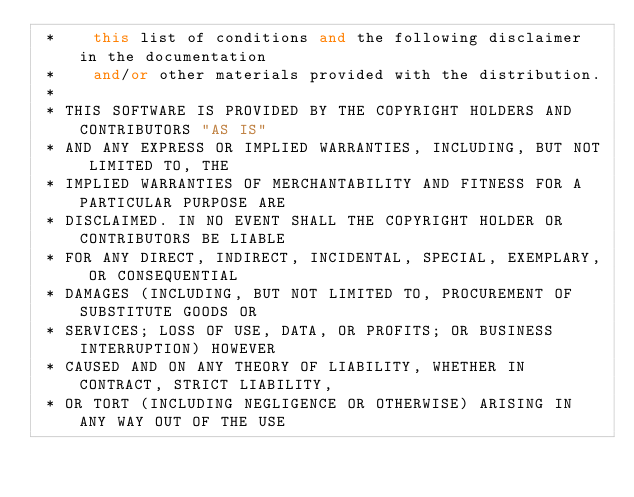Convert code to text. <code><loc_0><loc_0><loc_500><loc_500><_C++_> *    this list of conditions and the following disclaimer in the documentation
 *    and/or other materials provided with the distribution.
 *
 * THIS SOFTWARE IS PROVIDED BY THE COPYRIGHT HOLDERS AND CONTRIBUTORS "AS IS"
 * AND ANY EXPRESS OR IMPLIED WARRANTIES, INCLUDING, BUT NOT LIMITED TO, THE
 * IMPLIED WARRANTIES OF MERCHANTABILITY AND FITNESS FOR A PARTICULAR PURPOSE ARE
 * DISCLAIMED. IN NO EVENT SHALL THE COPYRIGHT HOLDER OR CONTRIBUTORS BE LIABLE
 * FOR ANY DIRECT, INDIRECT, INCIDENTAL, SPECIAL, EXEMPLARY, OR CONSEQUENTIAL
 * DAMAGES (INCLUDING, BUT NOT LIMITED TO, PROCUREMENT OF SUBSTITUTE GOODS OR
 * SERVICES; LOSS OF USE, DATA, OR PROFITS; OR BUSINESS INTERRUPTION) HOWEVER
 * CAUSED AND ON ANY THEORY OF LIABILITY, WHETHER IN CONTRACT, STRICT LIABILITY,
 * OR TORT (INCLUDING NEGLIGENCE OR OTHERWISE) ARISING IN ANY WAY OUT OF THE USE</code> 